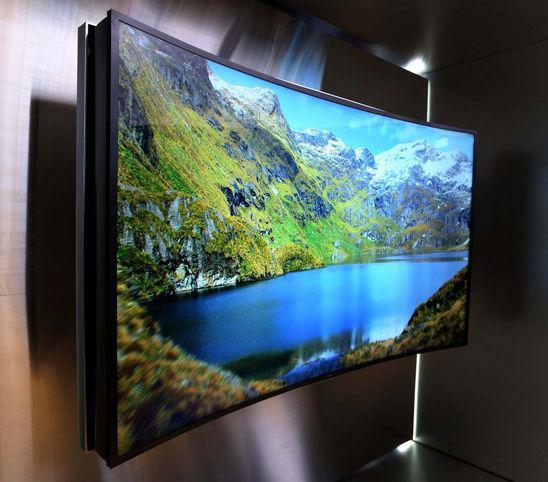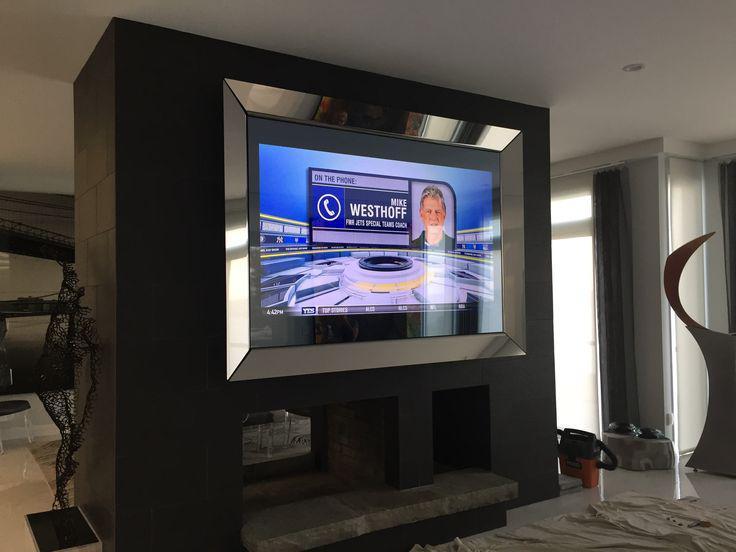The first image is the image on the left, the second image is the image on the right. Evaluate the accuracy of this statement regarding the images: "The right image contains two humans.". Is it true? Answer yes or no. No. 